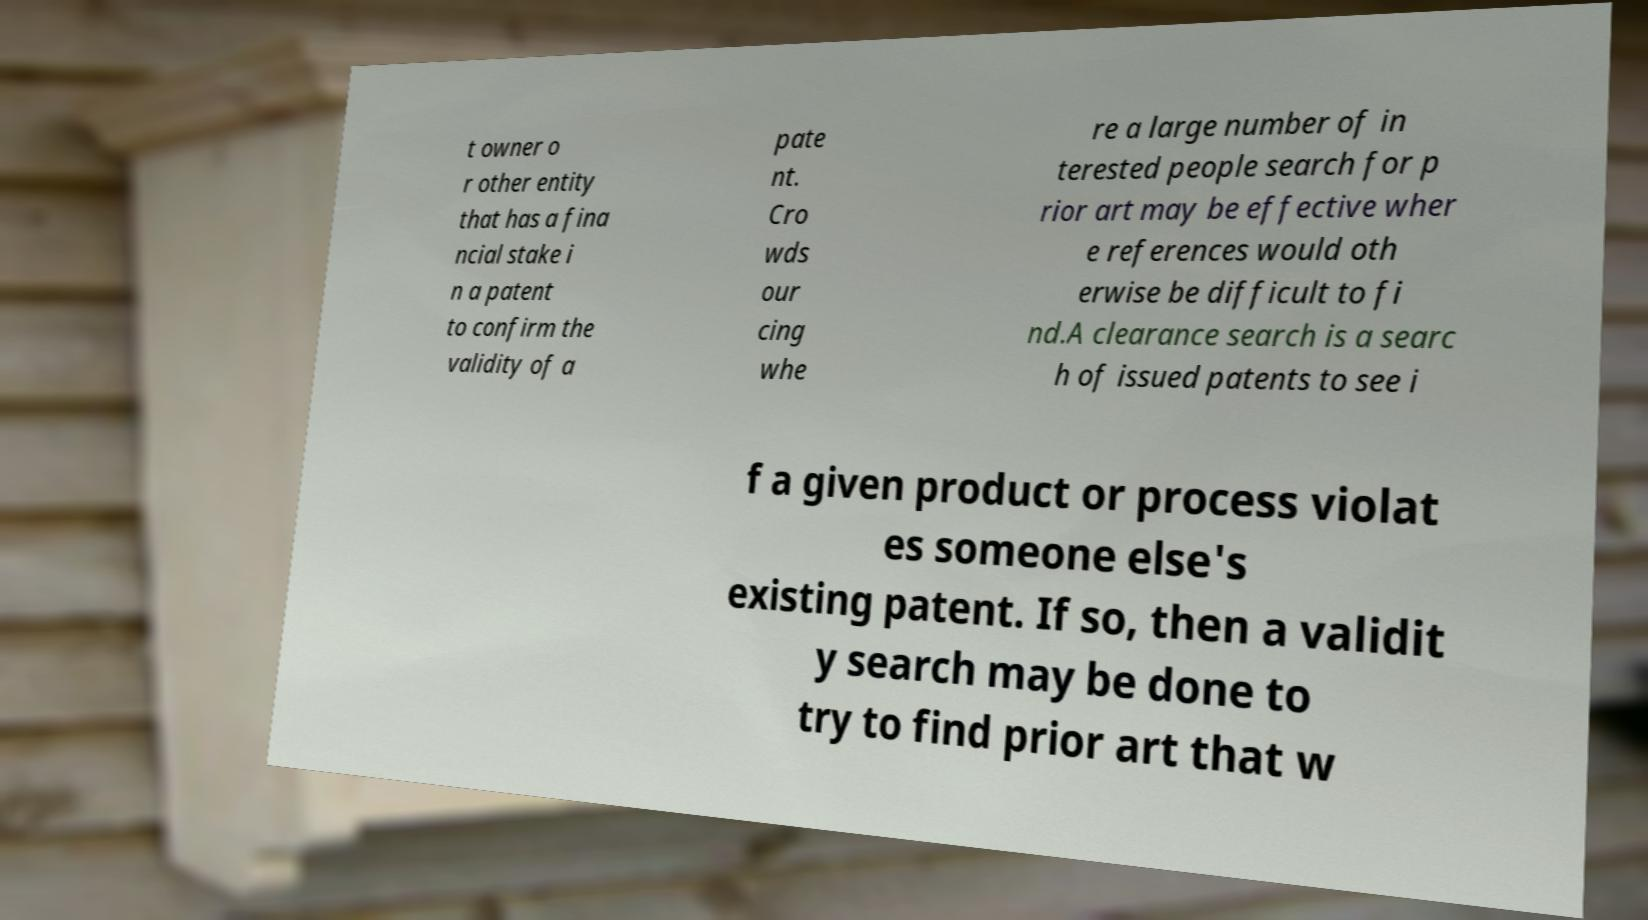Please identify and transcribe the text found in this image. t owner o r other entity that has a fina ncial stake i n a patent to confirm the validity of a pate nt. Cro wds our cing whe re a large number of in terested people search for p rior art may be effective wher e references would oth erwise be difficult to fi nd.A clearance search is a searc h of issued patents to see i f a given product or process violat es someone else's existing patent. If so, then a validit y search may be done to try to find prior art that w 